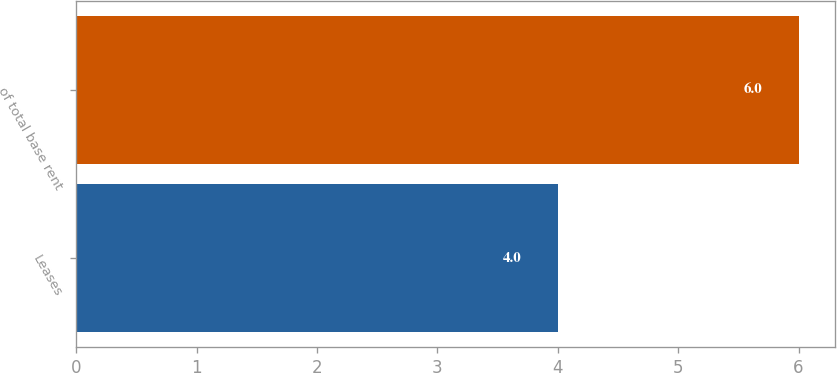Convert chart. <chart><loc_0><loc_0><loc_500><loc_500><bar_chart><fcel>Leases<fcel>of total base rent<nl><fcel>4<fcel>6<nl></chart> 